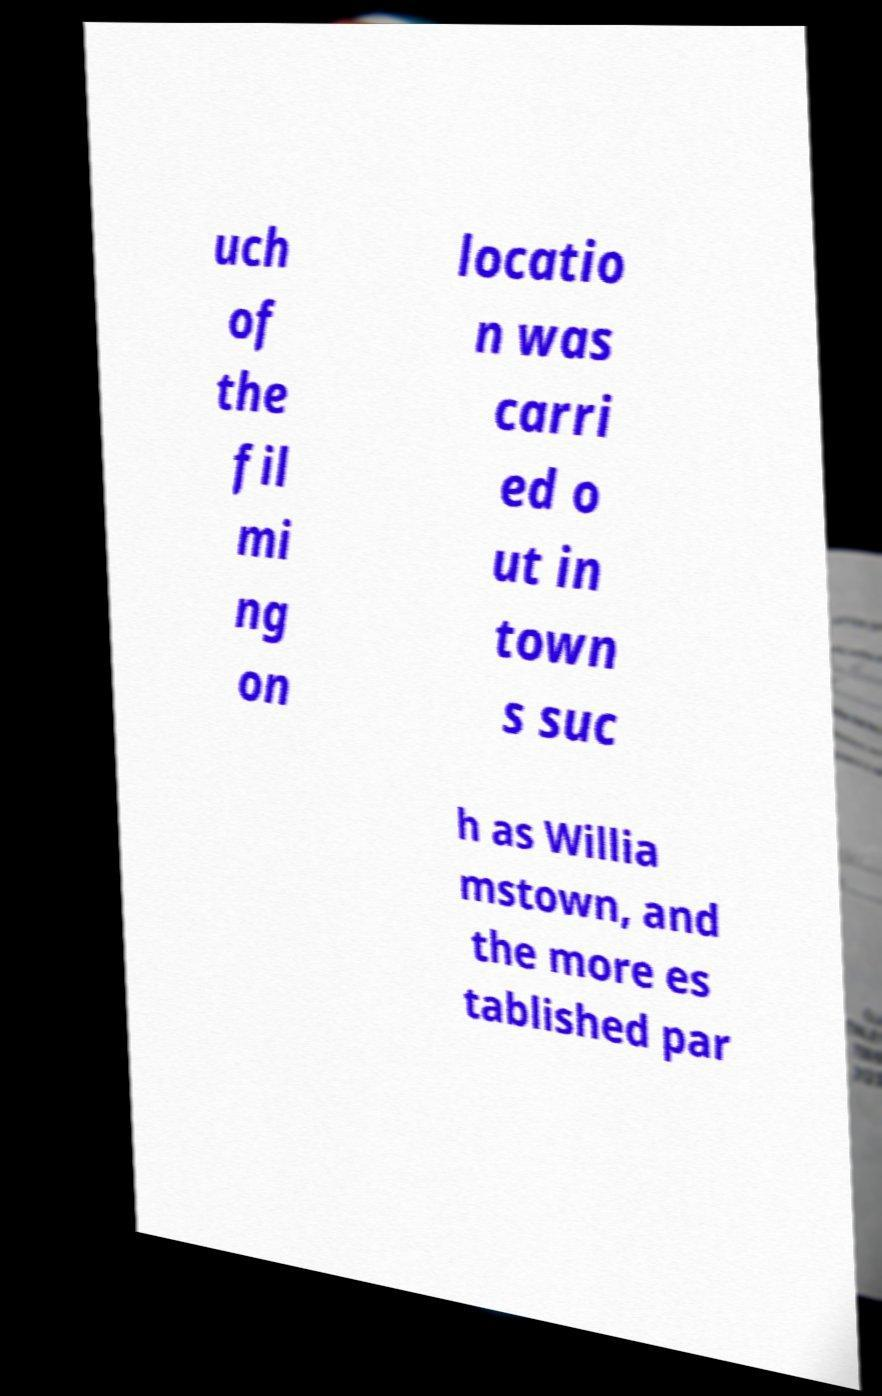Could you assist in decoding the text presented in this image and type it out clearly? uch of the fil mi ng on locatio n was carri ed o ut in town s suc h as Willia mstown, and the more es tablished par 